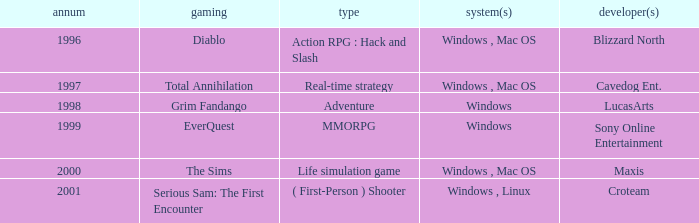What year is the Grim Fandango with a windows platform? 1998.0. 